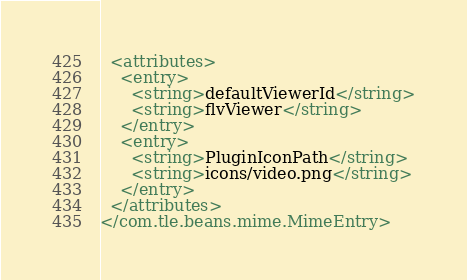Convert code to text. <code><loc_0><loc_0><loc_500><loc_500><_XML_>  <attributes>
    <entry>
      <string>defaultViewerId</string>
      <string>flvViewer</string>
    </entry>
    <entry>
      <string>PluginIconPath</string>
      <string>icons/video.png</string>
    </entry>
  </attributes>
</com.tle.beans.mime.MimeEntry></code> 